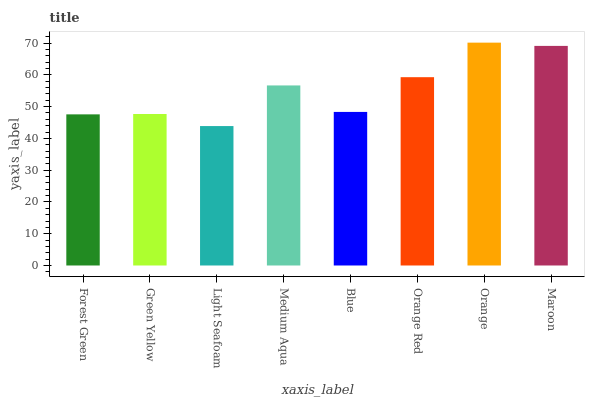Is Light Seafoam the minimum?
Answer yes or no. Yes. Is Orange the maximum?
Answer yes or no. Yes. Is Green Yellow the minimum?
Answer yes or no. No. Is Green Yellow the maximum?
Answer yes or no. No. Is Green Yellow greater than Forest Green?
Answer yes or no. Yes. Is Forest Green less than Green Yellow?
Answer yes or no. Yes. Is Forest Green greater than Green Yellow?
Answer yes or no. No. Is Green Yellow less than Forest Green?
Answer yes or no. No. Is Medium Aqua the high median?
Answer yes or no. Yes. Is Blue the low median?
Answer yes or no. Yes. Is Green Yellow the high median?
Answer yes or no. No. Is Green Yellow the low median?
Answer yes or no. No. 